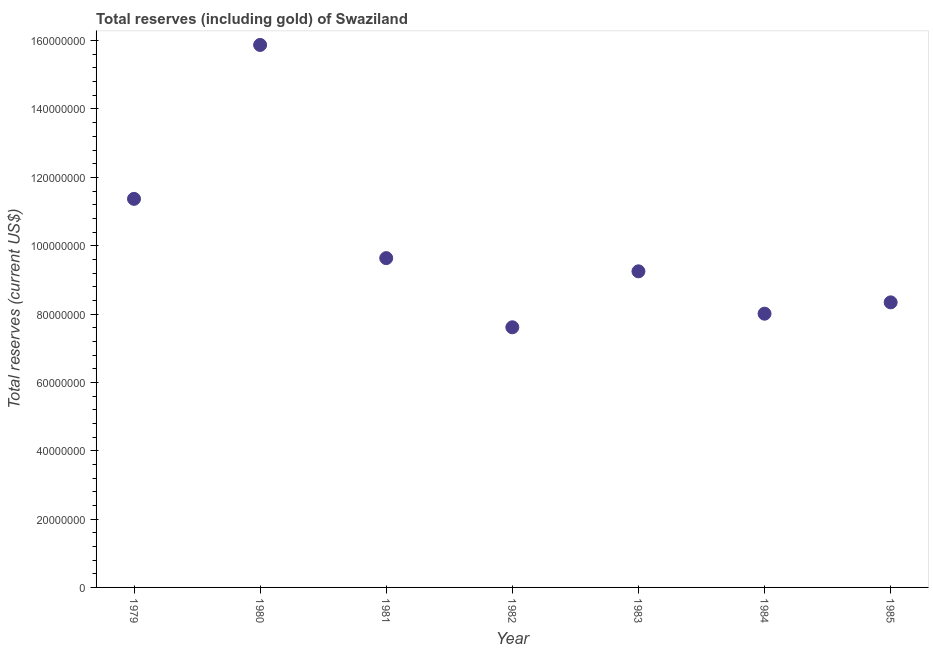What is the total reserves (including gold) in 1982?
Your response must be concise. 7.61e+07. Across all years, what is the maximum total reserves (including gold)?
Provide a succinct answer. 1.59e+08. Across all years, what is the minimum total reserves (including gold)?
Offer a very short reply. 7.61e+07. In which year was the total reserves (including gold) minimum?
Ensure brevity in your answer.  1982. What is the sum of the total reserves (including gold)?
Ensure brevity in your answer.  7.01e+08. What is the difference between the total reserves (including gold) in 1979 and 1983?
Offer a very short reply. 2.12e+07. What is the average total reserves (including gold) per year?
Provide a short and direct response. 1.00e+08. What is the median total reserves (including gold)?
Provide a short and direct response. 9.25e+07. In how many years, is the total reserves (including gold) greater than 52000000 US$?
Keep it short and to the point. 7. Do a majority of the years between 1980 and 1979 (inclusive) have total reserves (including gold) greater than 12000000 US$?
Your response must be concise. No. What is the ratio of the total reserves (including gold) in 1980 to that in 1983?
Provide a short and direct response. 1.72. Is the total reserves (including gold) in 1979 less than that in 1984?
Offer a very short reply. No. Is the difference between the total reserves (including gold) in 1983 and 1985 greater than the difference between any two years?
Your response must be concise. No. What is the difference between the highest and the second highest total reserves (including gold)?
Ensure brevity in your answer.  4.50e+07. Is the sum of the total reserves (including gold) in 1982 and 1985 greater than the maximum total reserves (including gold) across all years?
Provide a succinct answer. Yes. What is the difference between the highest and the lowest total reserves (including gold)?
Your response must be concise. 8.26e+07. In how many years, is the total reserves (including gold) greater than the average total reserves (including gold) taken over all years?
Your answer should be compact. 2. How many dotlines are there?
Give a very brief answer. 1. What is the difference between two consecutive major ticks on the Y-axis?
Your answer should be compact. 2.00e+07. What is the title of the graph?
Offer a very short reply. Total reserves (including gold) of Swaziland. What is the label or title of the Y-axis?
Your answer should be very brief. Total reserves (current US$). What is the Total reserves (current US$) in 1979?
Offer a terse response. 1.14e+08. What is the Total reserves (current US$) in 1980?
Your response must be concise. 1.59e+08. What is the Total reserves (current US$) in 1981?
Your answer should be compact. 9.64e+07. What is the Total reserves (current US$) in 1982?
Make the answer very short. 7.61e+07. What is the Total reserves (current US$) in 1983?
Keep it short and to the point. 9.25e+07. What is the Total reserves (current US$) in 1984?
Provide a succinct answer. 8.01e+07. What is the Total reserves (current US$) in 1985?
Ensure brevity in your answer.  8.34e+07. What is the difference between the Total reserves (current US$) in 1979 and 1980?
Offer a terse response. -4.50e+07. What is the difference between the Total reserves (current US$) in 1979 and 1981?
Ensure brevity in your answer.  1.73e+07. What is the difference between the Total reserves (current US$) in 1979 and 1982?
Ensure brevity in your answer.  3.76e+07. What is the difference between the Total reserves (current US$) in 1979 and 1983?
Give a very brief answer. 2.12e+07. What is the difference between the Total reserves (current US$) in 1979 and 1984?
Offer a terse response. 3.36e+07. What is the difference between the Total reserves (current US$) in 1979 and 1985?
Make the answer very short. 3.03e+07. What is the difference between the Total reserves (current US$) in 1980 and 1981?
Offer a terse response. 6.24e+07. What is the difference between the Total reserves (current US$) in 1980 and 1982?
Make the answer very short. 8.26e+07. What is the difference between the Total reserves (current US$) in 1980 and 1983?
Provide a short and direct response. 6.62e+07. What is the difference between the Total reserves (current US$) in 1980 and 1984?
Provide a succinct answer. 7.86e+07. What is the difference between the Total reserves (current US$) in 1980 and 1985?
Keep it short and to the point. 7.53e+07. What is the difference between the Total reserves (current US$) in 1981 and 1982?
Your answer should be very brief. 2.02e+07. What is the difference between the Total reserves (current US$) in 1981 and 1983?
Ensure brevity in your answer.  3.86e+06. What is the difference between the Total reserves (current US$) in 1981 and 1984?
Ensure brevity in your answer.  1.63e+07. What is the difference between the Total reserves (current US$) in 1981 and 1985?
Offer a terse response. 1.29e+07. What is the difference between the Total reserves (current US$) in 1982 and 1983?
Offer a very short reply. -1.64e+07. What is the difference between the Total reserves (current US$) in 1982 and 1984?
Give a very brief answer. -3.98e+06. What is the difference between the Total reserves (current US$) in 1982 and 1985?
Provide a succinct answer. -7.29e+06. What is the difference between the Total reserves (current US$) in 1983 and 1984?
Give a very brief answer. 1.24e+07. What is the difference between the Total reserves (current US$) in 1983 and 1985?
Provide a short and direct response. 9.08e+06. What is the difference between the Total reserves (current US$) in 1984 and 1985?
Offer a terse response. -3.32e+06. What is the ratio of the Total reserves (current US$) in 1979 to that in 1980?
Provide a short and direct response. 0.72. What is the ratio of the Total reserves (current US$) in 1979 to that in 1981?
Give a very brief answer. 1.18. What is the ratio of the Total reserves (current US$) in 1979 to that in 1982?
Your response must be concise. 1.49. What is the ratio of the Total reserves (current US$) in 1979 to that in 1983?
Offer a very short reply. 1.23. What is the ratio of the Total reserves (current US$) in 1979 to that in 1984?
Make the answer very short. 1.42. What is the ratio of the Total reserves (current US$) in 1979 to that in 1985?
Ensure brevity in your answer.  1.36. What is the ratio of the Total reserves (current US$) in 1980 to that in 1981?
Ensure brevity in your answer.  1.65. What is the ratio of the Total reserves (current US$) in 1980 to that in 1982?
Provide a succinct answer. 2.08. What is the ratio of the Total reserves (current US$) in 1980 to that in 1983?
Your answer should be compact. 1.72. What is the ratio of the Total reserves (current US$) in 1980 to that in 1984?
Your response must be concise. 1.98. What is the ratio of the Total reserves (current US$) in 1980 to that in 1985?
Your answer should be compact. 1.9. What is the ratio of the Total reserves (current US$) in 1981 to that in 1982?
Ensure brevity in your answer.  1.27. What is the ratio of the Total reserves (current US$) in 1981 to that in 1983?
Make the answer very short. 1.04. What is the ratio of the Total reserves (current US$) in 1981 to that in 1984?
Your answer should be very brief. 1.2. What is the ratio of the Total reserves (current US$) in 1981 to that in 1985?
Make the answer very short. 1.16. What is the ratio of the Total reserves (current US$) in 1982 to that in 1983?
Provide a succinct answer. 0.82. What is the ratio of the Total reserves (current US$) in 1982 to that in 1984?
Keep it short and to the point. 0.95. What is the ratio of the Total reserves (current US$) in 1982 to that in 1985?
Offer a very short reply. 0.91. What is the ratio of the Total reserves (current US$) in 1983 to that in 1984?
Keep it short and to the point. 1.16. What is the ratio of the Total reserves (current US$) in 1983 to that in 1985?
Your answer should be very brief. 1.11. 